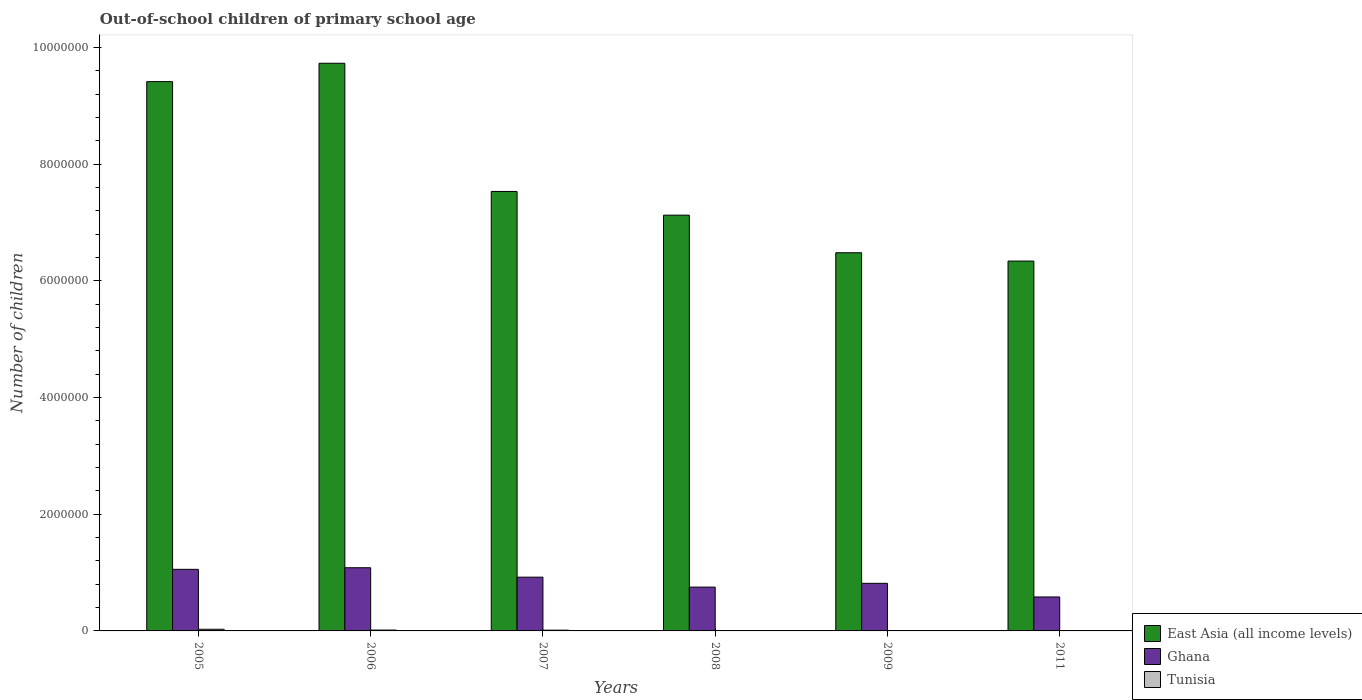How many bars are there on the 5th tick from the left?
Offer a terse response. 3. How many bars are there on the 2nd tick from the right?
Give a very brief answer. 3. What is the label of the 2nd group of bars from the left?
Your answer should be compact. 2006. In how many cases, is the number of bars for a given year not equal to the number of legend labels?
Provide a succinct answer. 0. What is the number of out-of-school children in Ghana in 2006?
Keep it short and to the point. 1.08e+06. Across all years, what is the maximum number of out-of-school children in Ghana?
Your response must be concise. 1.08e+06. Across all years, what is the minimum number of out-of-school children in Ghana?
Offer a very short reply. 5.82e+05. What is the total number of out-of-school children in Tunisia in the graph?
Offer a very short reply. 6.17e+04. What is the difference between the number of out-of-school children in Tunisia in 2007 and that in 2008?
Your answer should be very brief. 1.03e+04. What is the difference between the number of out-of-school children in Ghana in 2008 and the number of out-of-school children in Tunisia in 2009?
Ensure brevity in your answer.  7.49e+05. What is the average number of out-of-school children in Ghana per year?
Provide a succinct answer. 8.68e+05. In the year 2007, what is the difference between the number of out-of-school children in Tunisia and number of out-of-school children in Ghana?
Your response must be concise. -9.09e+05. In how many years, is the number of out-of-school children in Tunisia greater than 7200000?
Provide a succinct answer. 0. What is the ratio of the number of out-of-school children in Tunisia in 2007 to that in 2011?
Your answer should be compact. 6.67. Is the number of out-of-school children in East Asia (all income levels) in 2007 less than that in 2009?
Your answer should be compact. No. Is the difference between the number of out-of-school children in Tunisia in 2005 and 2009 greater than the difference between the number of out-of-school children in Ghana in 2005 and 2009?
Ensure brevity in your answer.  No. What is the difference between the highest and the second highest number of out-of-school children in Tunisia?
Keep it short and to the point. 1.40e+04. What is the difference between the highest and the lowest number of out-of-school children in Ghana?
Give a very brief answer. 5.01e+05. In how many years, is the number of out-of-school children in Ghana greater than the average number of out-of-school children in Ghana taken over all years?
Your response must be concise. 3. What does the 2nd bar from the left in 2008 represents?
Keep it short and to the point. Ghana. What does the 2nd bar from the right in 2006 represents?
Give a very brief answer. Ghana. Are the values on the major ticks of Y-axis written in scientific E-notation?
Offer a terse response. No. Does the graph contain any zero values?
Your answer should be very brief. No. Where does the legend appear in the graph?
Your answer should be compact. Bottom right. How many legend labels are there?
Offer a terse response. 3. How are the legend labels stacked?
Your answer should be compact. Vertical. What is the title of the graph?
Keep it short and to the point. Out-of-school children of primary school age. What is the label or title of the X-axis?
Keep it short and to the point. Years. What is the label or title of the Y-axis?
Your response must be concise. Number of children. What is the Number of children of East Asia (all income levels) in 2005?
Your answer should be compact. 9.42e+06. What is the Number of children in Ghana in 2005?
Offer a terse response. 1.06e+06. What is the Number of children in Tunisia in 2005?
Provide a short and direct response. 2.85e+04. What is the Number of children in East Asia (all income levels) in 2006?
Your answer should be compact. 9.73e+06. What is the Number of children of Ghana in 2006?
Your answer should be compact. 1.08e+06. What is the Number of children of Tunisia in 2006?
Provide a succinct answer. 1.45e+04. What is the Number of children of East Asia (all income levels) in 2007?
Make the answer very short. 7.53e+06. What is the Number of children of Ghana in 2007?
Provide a short and direct response. 9.21e+05. What is the Number of children in Tunisia in 2007?
Make the answer very short. 1.27e+04. What is the Number of children of East Asia (all income levels) in 2008?
Offer a terse response. 7.13e+06. What is the Number of children of Ghana in 2008?
Your answer should be compact. 7.51e+05. What is the Number of children in Tunisia in 2008?
Make the answer very short. 2323. What is the Number of children in East Asia (all income levels) in 2009?
Provide a succinct answer. 6.48e+06. What is the Number of children of Ghana in 2009?
Ensure brevity in your answer.  8.16e+05. What is the Number of children in Tunisia in 2009?
Offer a very short reply. 1825. What is the Number of children of East Asia (all income levels) in 2011?
Ensure brevity in your answer.  6.34e+06. What is the Number of children in Ghana in 2011?
Your response must be concise. 5.82e+05. What is the Number of children in Tunisia in 2011?
Keep it short and to the point. 1898. Across all years, what is the maximum Number of children in East Asia (all income levels)?
Your answer should be very brief. 9.73e+06. Across all years, what is the maximum Number of children in Ghana?
Keep it short and to the point. 1.08e+06. Across all years, what is the maximum Number of children of Tunisia?
Provide a succinct answer. 2.85e+04. Across all years, what is the minimum Number of children of East Asia (all income levels)?
Provide a short and direct response. 6.34e+06. Across all years, what is the minimum Number of children in Ghana?
Offer a very short reply. 5.82e+05. Across all years, what is the minimum Number of children in Tunisia?
Make the answer very short. 1825. What is the total Number of children of East Asia (all income levels) in the graph?
Provide a short and direct response. 4.66e+07. What is the total Number of children of Ghana in the graph?
Offer a terse response. 5.21e+06. What is the total Number of children of Tunisia in the graph?
Provide a succinct answer. 6.17e+04. What is the difference between the Number of children of East Asia (all income levels) in 2005 and that in 2006?
Give a very brief answer. -3.15e+05. What is the difference between the Number of children in Ghana in 2005 and that in 2006?
Provide a succinct answer. -2.72e+04. What is the difference between the Number of children in Tunisia in 2005 and that in 2006?
Ensure brevity in your answer.  1.40e+04. What is the difference between the Number of children in East Asia (all income levels) in 2005 and that in 2007?
Your answer should be very brief. 1.88e+06. What is the difference between the Number of children of Ghana in 2005 and that in 2007?
Provide a succinct answer. 1.34e+05. What is the difference between the Number of children of Tunisia in 2005 and that in 2007?
Offer a terse response. 1.58e+04. What is the difference between the Number of children in East Asia (all income levels) in 2005 and that in 2008?
Keep it short and to the point. 2.29e+06. What is the difference between the Number of children in Ghana in 2005 and that in 2008?
Your answer should be very brief. 3.05e+05. What is the difference between the Number of children of Tunisia in 2005 and that in 2008?
Your response must be concise. 2.62e+04. What is the difference between the Number of children of East Asia (all income levels) in 2005 and that in 2009?
Give a very brief answer. 2.93e+06. What is the difference between the Number of children of Ghana in 2005 and that in 2009?
Your response must be concise. 2.40e+05. What is the difference between the Number of children in Tunisia in 2005 and that in 2009?
Offer a terse response. 2.66e+04. What is the difference between the Number of children in East Asia (all income levels) in 2005 and that in 2011?
Ensure brevity in your answer.  3.08e+06. What is the difference between the Number of children of Ghana in 2005 and that in 2011?
Ensure brevity in your answer.  4.73e+05. What is the difference between the Number of children in Tunisia in 2005 and that in 2011?
Give a very brief answer. 2.66e+04. What is the difference between the Number of children in East Asia (all income levels) in 2006 and that in 2007?
Offer a very short reply. 2.20e+06. What is the difference between the Number of children in Ghana in 2006 and that in 2007?
Provide a short and direct response. 1.62e+05. What is the difference between the Number of children in Tunisia in 2006 and that in 2007?
Make the answer very short. 1848. What is the difference between the Number of children of East Asia (all income levels) in 2006 and that in 2008?
Offer a very short reply. 2.60e+06. What is the difference between the Number of children of Ghana in 2006 and that in 2008?
Your answer should be very brief. 3.32e+05. What is the difference between the Number of children in Tunisia in 2006 and that in 2008?
Your answer should be compact. 1.22e+04. What is the difference between the Number of children in East Asia (all income levels) in 2006 and that in 2009?
Provide a succinct answer. 3.25e+06. What is the difference between the Number of children in Ghana in 2006 and that in 2009?
Provide a short and direct response. 2.67e+05. What is the difference between the Number of children of Tunisia in 2006 and that in 2009?
Your response must be concise. 1.27e+04. What is the difference between the Number of children in East Asia (all income levels) in 2006 and that in 2011?
Give a very brief answer. 3.39e+06. What is the difference between the Number of children in Ghana in 2006 and that in 2011?
Your response must be concise. 5.01e+05. What is the difference between the Number of children of Tunisia in 2006 and that in 2011?
Offer a terse response. 1.26e+04. What is the difference between the Number of children of East Asia (all income levels) in 2007 and that in 2008?
Your answer should be compact. 4.06e+05. What is the difference between the Number of children in Ghana in 2007 and that in 2008?
Your response must be concise. 1.70e+05. What is the difference between the Number of children in Tunisia in 2007 and that in 2008?
Give a very brief answer. 1.03e+04. What is the difference between the Number of children in East Asia (all income levels) in 2007 and that in 2009?
Keep it short and to the point. 1.05e+06. What is the difference between the Number of children of Ghana in 2007 and that in 2009?
Give a very brief answer. 1.05e+05. What is the difference between the Number of children of Tunisia in 2007 and that in 2009?
Offer a terse response. 1.08e+04. What is the difference between the Number of children of East Asia (all income levels) in 2007 and that in 2011?
Your answer should be very brief. 1.19e+06. What is the difference between the Number of children of Ghana in 2007 and that in 2011?
Provide a short and direct response. 3.39e+05. What is the difference between the Number of children in Tunisia in 2007 and that in 2011?
Your answer should be very brief. 1.08e+04. What is the difference between the Number of children of East Asia (all income levels) in 2008 and that in 2009?
Ensure brevity in your answer.  6.44e+05. What is the difference between the Number of children in Ghana in 2008 and that in 2009?
Ensure brevity in your answer.  -6.48e+04. What is the difference between the Number of children in Tunisia in 2008 and that in 2009?
Ensure brevity in your answer.  498. What is the difference between the Number of children of East Asia (all income levels) in 2008 and that in 2011?
Provide a succinct answer. 7.87e+05. What is the difference between the Number of children in Ghana in 2008 and that in 2011?
Keep it short and to the point. 1.69e+05. What is the difference between the Number of children in Tunisia in 2008 and that in 2011?
Offer a very short reply. 425. What is the difference between the Number of children in East Asia (all income levels) in 2009 and that in 2011?
Make the answer very short. 1.43e+05. What is the difference between the Number of children of Ghana in 2009 and that in 2011?
Give a very brief answer. 2.34e+05. What is the difference between the Number of children in Tunisia in 2009 and that in 2011?
Your answer should be very brief. -73. What is the difference between the Number of children in East Asia (all income levels) in 2005 and the Number of children in Ghana in 2006?
Your answer should be compact. 8.33e+06. What is the difference between the Number of children of East Asia (all income levels) in 2005 and the Number of children of Tunisia in 2006?
Provide a succinct answer. 9.40e+06. What is the difference between the Number of children of Ghana in 2005 and the Number of children of Tunisia in 2006?
Provide a short and direct response. 1.04e+06. What is the difference between the Number of children of East Asia (all income levels) in 2005 and the Number of children of Ghana in 2007?
Provide a succinct answer. 8.49e+06. What is the difference between the Number of children in East Asia (all income levels) in 2005 and the Number of children in Tunisia in 2007?
Provide a succinct answer. 9.40e+06. What is the difference between the Number of children in Ghana in 2005 and the Number of children in Tunisia in 2007?
Keep it short and to the point. 1.04e+06. What is the difference between the Number of children in East Asia (all income levels) in 2005 and the Number of children in Ghana in 2008?
Your response must be concise. 8.67e+06. What is the difference between the Number of children of East Asia (all income levels) in 2005 and the Number of children of Tunisia in 2008?
Offer a terse response. 9.41e+06. What is the difference between the Number of children in Ghana in 2005 and the Number of children in Tunisia in 2008?
Provide a succinct answer. 1.05e+06. What is the difference between the Number of children of East Asia (all income levels) in 2005 and the Number of children of Ghana in 2009?
Ensure brevity in your answer.  8.60e+06. What is the difference between the Number of children in East Asia (all income levels) in 2005 and the Number of children in Tunisia in 2009?
Keep it short and to the point. 9.41e+06. What is the difference between the Number of children of Ghana in 2005 and the Number of children of Tunisia in 2009?
Ensure brevity in your answer.  1.05e+06. What is the difference between the Number of children of East Asia (all income levels) in 2005 and the Number of children of Ghana in 2011?
Offer a very short reply. 8.83e+06. What is the difference between the Number of children in East Asia (all income levels) in 2005 and the Number of children in Tunisia in 2011?
Give a very brief answer. 9.41e+06. What is the difference between the Number of children in Ghana in 2005 and the Number of children in Tunisia in 2011?
Make the answer very short. 1.05e+06. What is the difference between the Number of children of East Asia (all income levels) in 2006 and the Number of children of Ghana in 2007?
Ensure brevity in your answer.  8.81e+06. What is the difference between the Number of children in East Asia (all income levels) in 2006 and the Number of children in Tunisia in 2007?
Ensure brevity in your answer.  9.72e+06. What is the difference between the Number of children in Ghana in 2006 and the Number of children in Tunisia in 2007?
Keep it short and to the point. 1.07e+06. What is the difference between the Number of children in East Asia (all income levels) in 2006 and the Number of children in Ghana in 2008?
Offer a very short reply. 8.98e+06. What is the difference between the Number of children of East Asia (all income levels) in 2006 and the Number of children of Tunisia in 2008?
Give a very brief answer. 9.73e+06. What is the difference between the Number of children in Ghana in 2006 and the Number of children in Tunisia in 2008?
Your response must be concise. 1.08e+06. What is the difference between the Number of children in East Asia (all income levels) in 2006 and the Number of children in Ghana in 2009?
Keep it short and to the point. 8.92e+06. What is the difference between the Number of children of East Asia (all income levels) in 2006 and the Number of children of Tunisia in 2009?
Provide a short and direct response. 9.73e+06. What is the difference between the Number of children of Ghana in 2006 and the Number of children of Tunisia in 2009?
Offer a terse response. 1.08e+06. What is the difference between the Number of children in East Asia (all income levels) in 2006 and the Number of children in Ghana in 2011?
Offer a terse response. 9.15e+06. What is the difference between the Number of children in East Asia (all income levels) in 2006 and the Number of children in Tunisia in 2011?
Provide a succinct answer. 9.73e+06. What is the difference between the Number of children of Ghana in 2006 and the Number of children of Tunisia in 2011?
Offer a very short reply. 1.08e+06. What is the difference between the Number of children of East Asia (all income levels) in 2007 and the Number of children of Ghana in 2008?
Your answer should be very brief. 6.78e+06. What is the difference between the Number of children of East Asia (all income levels) in 2007 and the Number of children of Tunisia in 2008?
Make the answer very short. 7.53e+06. What is the difference between the Number of children in Ghana in 2007 and the Number of children in Tunisia in 2008?
Provide a short and direct response. 9.19e+05. What is the difference between the Number of children in East Asia (all income levels) in 2007 and the Number of children in Ghana in 2009?
Give a very brief answer. 6.72e+06. What is the difference between the Number of children of East Asia (all income levels) in 2007 and the Number of children of Tunisia in 2009?
Give a very brief answer. 7.53e+06. What is the difference between the Number of children of Ghana in 2007 and the Number of children of Tunisia in 2009?
Keep it short and to the point. 9.20e+05. What is the difference between the Number of children in East Asia (all income levels) in 2007 and the Number of children in Ghana in 2011?
Offer a very short reply. 6.95e+06. What is the difference between the Number of children of East Asia (all income levels) in 2007 and the Number of children of Tunisia in 2011?
Keep it short and to the point. 7.53e+06. What is the difference between the Number of children of Ghana in 2007 and the Number of children of Tunisia in 2011?
Your answer should be very brief. 9.19e+05. What is the difference between the Number of children in East Asia (all income levels) in 2008 and the Number of children in Ghana in 2009?
Your response must be concise. 6.31e+06. What is the difference between the Number of children of East Asia (all income levels) in 2008 and the Number of children of Tunisia in 2009?
Provide a short and direct response. 7.13e+06. What is the difference between the Number of children of Ghana in 2008 and the Number of children of Tunisia in 2009?
Provide a succinct answer. 7.49e+05. What is the difference between the Number of children of East Asia (all income levels) in 2008 and the Number of children of Ghana in 2011?
Give a very brief answer. 6.54e+06. What is the difference between the Number of children in East Asia (all income levels) in 2008 and the Number of children in Tunisia in 2011?
Your response must be concise. 7.13e+06. What is the difference between the Number of children of Ghana in 2008 and the Number of children of Tunisia in 2011?
Ensure brevity in your answer.  7.49e+05. What is the difference between the Number of children in East Asia (all income levels) in 2009 and the Number of children in Ghana in 2011?
Provide a succinct answer. 5.90e+06. What is the difference between the Number of children in East Asia (all income levels) in 2009 and the Number of children in Tunisia in 2011?
Keep it short and to the point. 6.48e+06. What is the difference between the Number of children in Ghana in 2009 and the Number of children in Tunisia in 2011?
Ensure brevity in your answer.  8.14e+05. What is the average Number of children of East Asia (all income levels) per year?
Keep it short and to the point. 7.77e+06. What is the average Number of children in Ghana per year?
Offer a very short reply. 8.68e+05. What is the average Number of children of Tunisia per year?
Offer a very short reply. 1.03e+04. In the year 2005, what is the difference between the Number of children of East Asia (all income levels) and Number of children of Ghana?
Ensure brevity in your answer.  8.36e+06. In the year 2005, what is the difference between the Number of children of East Asia (all income levels) and Number of children of Tunisia?
Keep it short and to the point. 9.39e+06. In the year 2005, what is the difference between the Number of children in Ghana and Number of children in Tunisia?
Provide a short and direct response. 1.03e+06. In the year 2006, what is the difference between the Number of children in East Asia (all income levels) and Number of children in Ghana?
Your answer should be very brief. 8.65e+06. In the year 2006, what is the difference between the Number of children in East Asia (all income levels) and Number of children in Tunisia?
Your response must be concise. 9.72e+06. In the year 2006, what is the difference between the Number of children of Ghana and Number of children of Tunisia?
Your answer should be compact. 1.07e+06. In the year 2007, what is the difference between the Number of children of East Asia (all income levels) and Number of children of Ghana?
Offer a terse response. 6.61e+06. In the year 2007, what is the difference between the Number of children in East Asia (all income levels) and Number of children in Tunisia?
Keep it short and to the point. 7.52e+06. In the year 2007, what is the difference between the Number of children of Ghana and Number of children of Tunisia?
Give a very brief answer. 9.09e+05. In the year 2008, what is the difference between the Number of children of East Asia (all income levels) and Number of children of Ghana?
Give a very brief answer. 6.38e+06. In the year 2008, what is the difference between the Number of children in East Asia (all income levels) and Number of children in Tunisia?
Give a very brief answer. 7.12e+06. In the year 2008, what is the difference between the Number of children in Ghana and Number of children in Tunisia?
Ensure brevity in your answer.  7.49e+05. In the year 2009, what is the difference between the Number of children of East Asia (all income levels) and Number of children of Ghana?
Your answer should be very brief. 5.67e+06. In the year 2009, what is the difference between the Number of children of East Asia (all income levels) and Number of children of Tunisia?
Your answer should be compact. 6.48e+06. In the year 2009, what is the difference between the Number of children in Ghana and Number of children in Tunisia?
Your answer should be very brief. 8.14e+05. In the year 2011, what is the difference between the Number of children in East Asia (all income levels) and Number of children in Ghana?
Offer a very short reply. 5.76e+06. In the year 2011, what is the difference between the Number of children of East Asia (all income levels) and Number of children of Tunisia?
Give a very brief answer. 6.34e+06. In the year 2011, what is the difference between the Number of children of Ghana and Number of children of Tunisia?
Your answer should be very brief. 5.80e+05. What is the ratio of the Number of children in East Asia (all income levels) in 2005 to that in 2006?
Ensure brevity in your answer.  0.97. What is the ratio of the Number of children of Ghana in 2005 to that in 2006?
Make the answer very short. 0.97. What is the ratio of the Number of children of Tunisia in 2005 to that in 2006?
Ensure brevity in your answer.  1.96. What is the ratio of the Number of children in East Asia (all income levels) in 2005 to that in 2007?
Keep it short and to the point. 1.25. What is the ratio of the Number of children of Ghana in 2005 to that in 2007?
Offer a very short reply. 1.15. What is the ratio of the Number of children of Tunisia in 2005 to that in 2007?
Provide a succinct answer. 2.25. What is the ratio of the Number of children in East Asia (all income levels) in 2005 to that in 2008?
Your response must be concise. 1.32. What is the ratio of the Number of children of Ghana in 2005 to that in 2008?
Provide a short and direct response. 1.41. What is the ratio of the Number of children in Tunisia in 2005 to that in 2008?
Provide a succinct answer. 12.26. What is the ratio of the Number of children of East Asia (all income levels) in 2005 to that in 2009?
Your response must be concise. 1.45. What is the ratio of the Number of children of Ghana in 2005 to that in 2009?
Your answer should be compact. 1.29. What is the ratio of the Number of children in Tunisia in 2005 to that in 2009?
Offer a terse response. 15.6. What is the ratio of the Number of children in East Asia (all income levels) in 2005 to that in 2011?
Ensure brevity in your answer.  1.49. What is the ratio of the Number of children in Ghana in 2005 to that in 2011?
Offer a very short reply. 1.81. What is the ratio of the Number of children of Tunisia in 2005 to that in 2011?
Offer a terse response. 15. What is the ratio of the Number of children of East Asia (all income levels) in 2006 to that in 2007?
Keep it short and to the point. 1.29. What is the ratio of the Number of children in Ghana in 2006 to that in 2007?
Your answer should be compact. 1.18. What is the ratio of the Number of children of Tunisia in 2006 to that in 2007?
Your answer should be very brief. 1.15. What is the ratio of the Number of children of East Asia (all income levels) in 2006 to that in 2008?
Give a very brief answer. 1.37. What is the ratio of the Number of children in Ghana in 2006 to that in 2008?
Make the answer very short. 1.44. What is the ratio of the Number of children in Tunisia in 2006 to that in 2008?
Your answer should be very brief. 6.25. What is the ratio of the Number of children of East Asia (all income levels) in 2006 to that in 2009?
Offer a terse response. 1.5. What is the ratio of the Number of children in Ghana in 2006 to that in 2009?
Your answer should be compact. 1.33. What is the ratio of the Number of children in Tunisia in 2006 to that in 2009?
Offer a terse response. 7.95. What is the ratio of the Number of children in East Asia (all income levels) in 2006 to that in 2011?
Give a very brief answer. 1.53. What is the ratio of the Number of children in Ghana in 2006 to that in 2011?
Make the answer very short. 1.86. What is the ratio of the Number of children of Tunisia in 2006 to that in 2011?
Offer a very short reply. 7.65. What is the ratio of the Number of children of East Asia (all income levels) in 2007 to that in 2008?
Offer a terse response. 1.06. What is the ratio of the Number of children in Ghana in 2007 to that in 2008?
Offer a very short reply. 1.23. What is the ratio of the Number of children of Tunisia in 2007 to that in 2008?
Keep it short and to the point. 5.45. What is the ratio of the Number of children in East Asia (all income levels) in 2007 to that in 2009?
Your answer should be compact. 1.16. What is the ratio of the Number of children of Ghana in 2007 to that in 2009?
Provide a short and direct response. 1.13. What is the ratio of the Number of children of Tunisia in 2007 to that in 2009?
Your answer should be very brief. 6.94. What is the ratio of the Number of children in East Asia (all income levels) in 2007 to that in 2011?
Keep it short and to the point. 1.19. What is the ratio of the Number of children in Ghana in 2007 to that in 2011?
Your answer should be very brief. 1.58. What is the ratio of the Number of children in Tunisia in 2007 to that in 2011?
Your response must be concise. 6.67. What is the ratio of the Number of children in East Asia (all income levels) in 2008 to that in 2009?
Your answer should be very brief. 1.1. What is the ratio of the Number of children of Ghana in 2008 to that in 2009?
Offer a very short reply. 0.92. What is the ratio of the Number of children in Tunisia in 2008 to that in 2009?
Your answer should be very brief. 1.27. What is the ratio of the Number of children of East Asia (all income levels) in 2008 to that in 2011?
Ensure brevity in your answer.  1.12. What is the ratio of the Number of children in Ghana in 2008 to that in 2011?
Give a very brief answer. 1.29. What is the ratio of the Number of children of Tunisia in 2008 to that in 2011?
Keep it short and to the point. 1.22. What is the ratio of the Number of children of East Asia (all income levels) in 2009 to that in 2011?
Offer a terse response. 1.02. What is the ratio of the Number of children in Ghana in 2009 to that in 2011?
Make the answer very short. 1.4. What is the ratio of the Number of children in Tunisia in 2009 to that in 2011?
Your response must be concise. 0.96. What is the difference between the highest and the second highest Number of children of East Asia (all income levels)?
Ensure brevity in your answer.  3.15e+05. What is the difference between the highest and the second highest Number of children of Ghana?
Your response must be concise. 2.72e+04. What is the difference between the highest and the second highest Number of children in Tunisia?
Give a very brief answer. 1.40e+04. What is the difference between the highest and the lowest Number of children in East Asia (all income levels)?
Your answer should be very brief. 3.39e+06. What is the difference between the highest and the lowest Number of children in Ghana?
Your answer should be very brief. 5.01e+05. What is the difference between the highest and the lowest Number of children in Tunisia?
Offer a very short reply. 2.66e+04. 